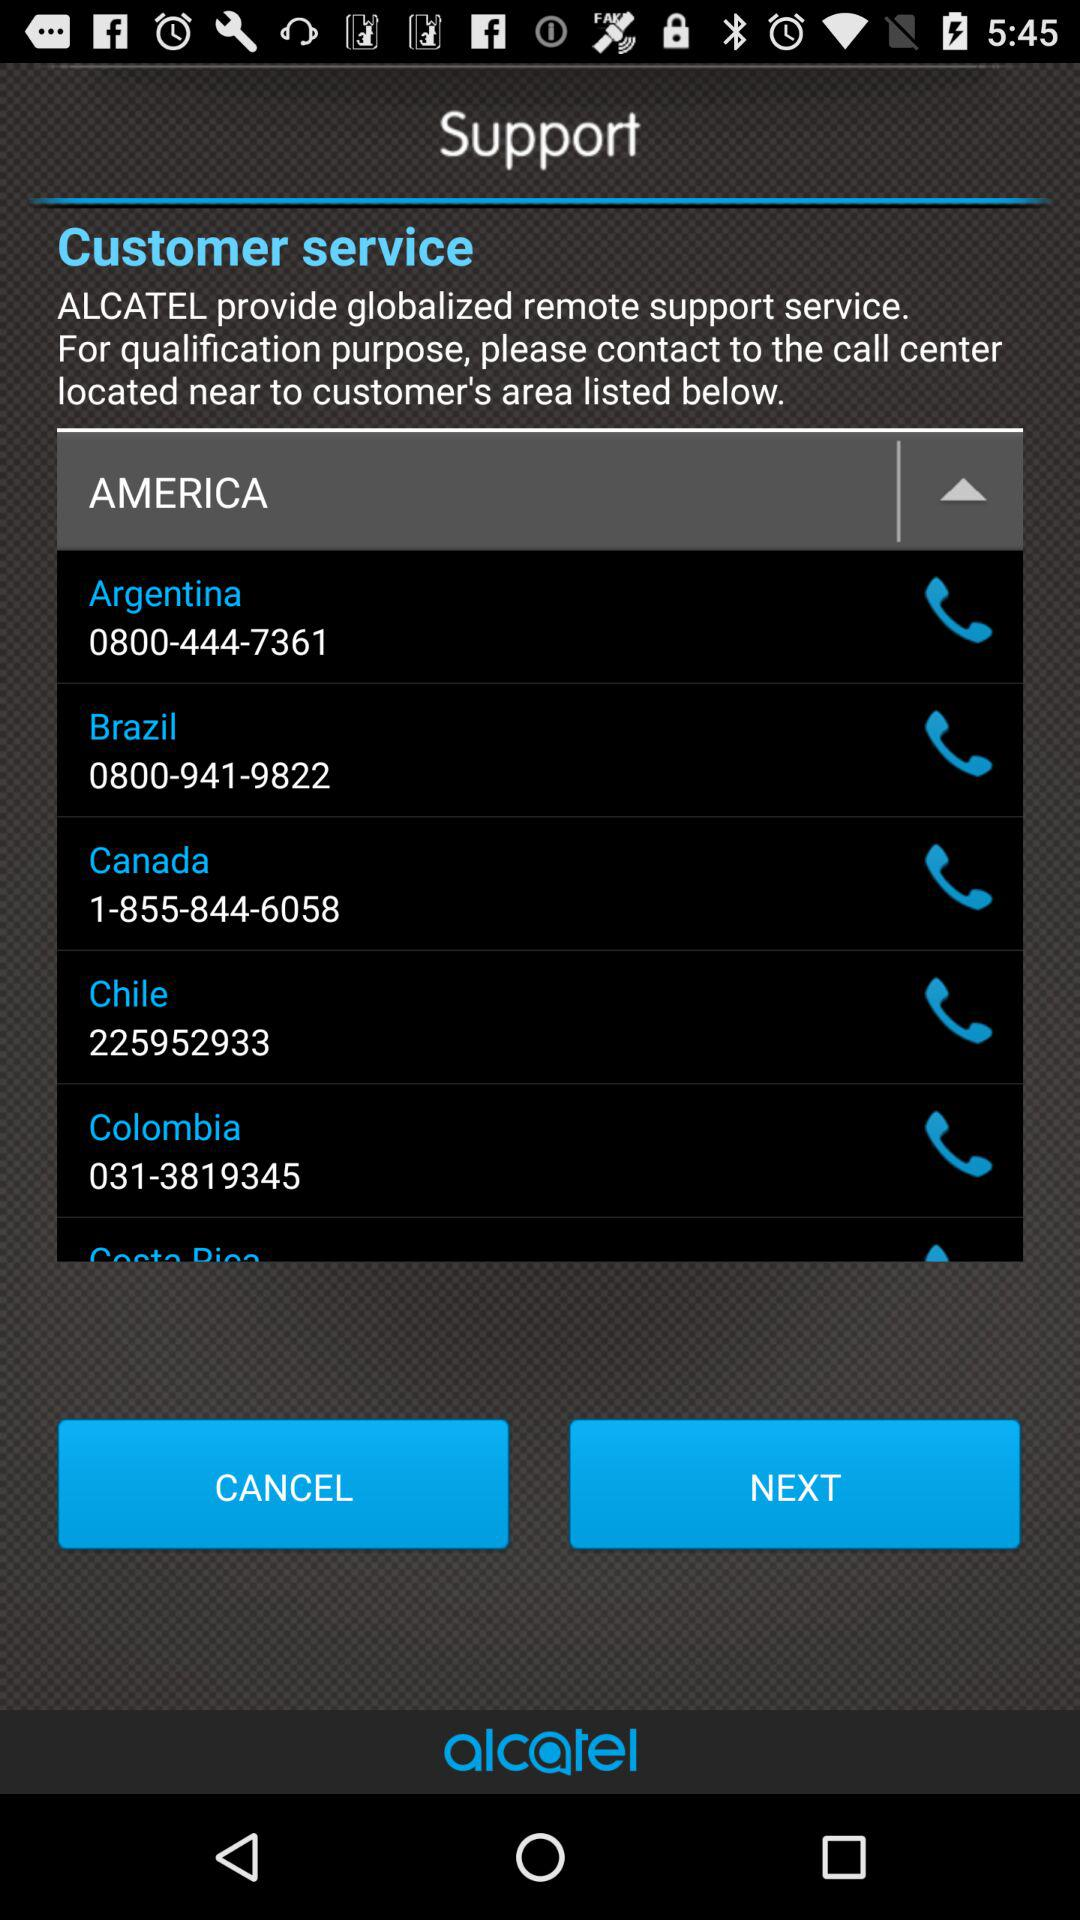What is the number for Brazil? The number is 0800-941-9822. 